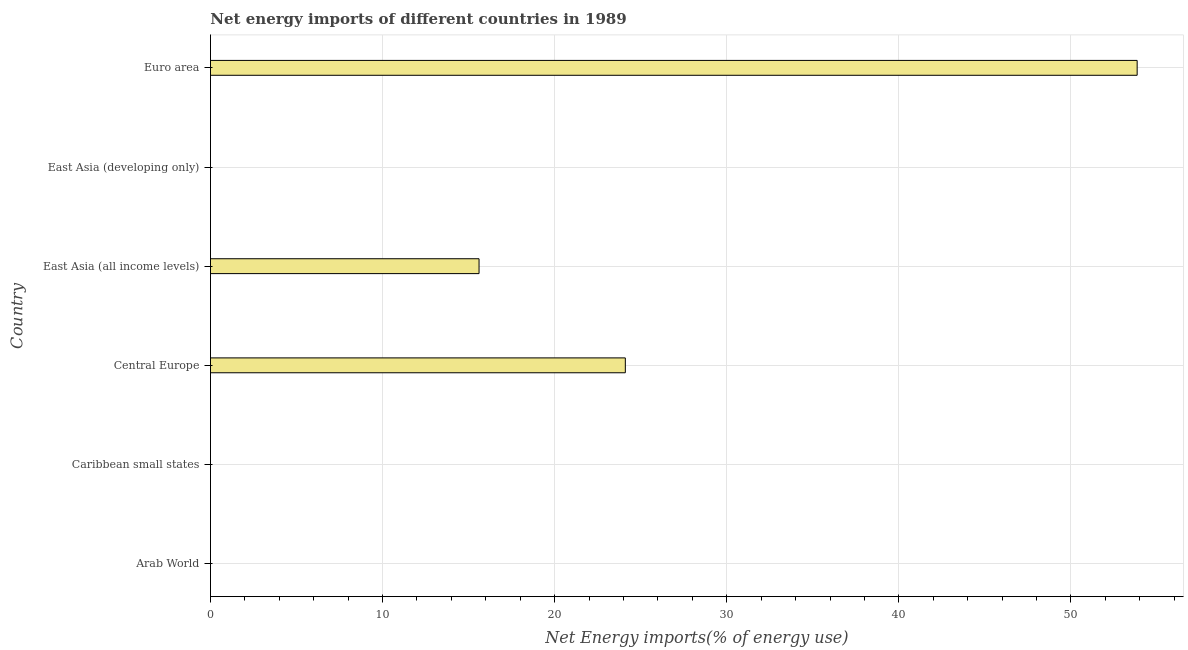Does the graph contain any zero values?
Ensure brevity in your answer.  Yes. What is the title of the graph?
Offer a terse response. Net energy imports of different countries in 1989. What is the label or title of the X-axis?
Your response must be concise. Net Energy imports(% of energy use). What is the label or title of the Y-axis?
Make the answer very short. Country. What is the energy imports in Caribbean small states?
Keep it short and to the point. 0. Across all countries, what is the maximum energy imports?
Keep it short and to the point. 53.85. Across all countries, what is the minimum energy imports?
Give a very brief answer. 0. In which country was the energy imports maximum?
Your response must be concise. Euro area. What is the sum of the energy imports?
Offer a very short reply. 93.56. What is the average energy imports per country?
Your answer should be compact. 15.59. What is the median energy imports?
Your response must be concise. 7.8. In how many countries, is the energy imports greater than 24 %?
Keep it short and to the point. 2. What is the ratio of the energy imports in East Asia (all income levels) to that in Euro area?
Your answer should be compact. 0.29. What is the difference between the highest and the second highest energy imports?
Make the answer very short. 29.74. Is the sum of the energy imports in East Asia (all income levels) and Euro area greater than the maximum energy imports across all countries?
Keep it short and to the point. Yes. What is the difference between the highest and the lowest energy imports?
Your answer should be compact. 53.85. In how many countries, is the energy imports greater than the average energy imports taken over all countries?
Your response must be concise. 3. How many bars are there?
Your response must be concise. 3. How many countries are there in the graph?
Offer a very short reply. 6. What is the difference between two consecutive major ticks on the X-axis?
Your response must be concise. 10. What is the Net Energy imports(% of energy use) in Caribbean small states?
Provide a short and direct response. 0. What is the Net Energy imports(% of energy use) in Central Europe?
Ensure brevity in your answer.  24.11. What is the Net Energy imports(% of energy use) of East Asia (all income levels)?
Give a very brief answer. 15.61. What is the Net Energy imports(% of energy use) of East Asia (developing only)?
Your response must be concise. 0. What is the Net Energy imports(% of energy use) of Euro area?
Offer a terse response. 53.85. What is the difference between the Net Energy imports(% of energy use) in Central Europe and East Asia (all income levels)?
Give a very brief answer. 8.5. What is the difference between the Net Energy imports(% of energy use) in Central Europe and Euro area?
Your answer should be very brief. -29.74. What is the difference between the Net Energy imports(% of energy use) in East Asia (all income levels) and Euro area?
Offer a very short reply. -38.24. What is the ratio of the Net Energy imports(% of energy use) in Central Europe to that in East Asia (all income levels)?
Your answer should be very brief. 1.54. What is the ratio of the Net Energy imports(% of energy use) in Central Europe to that in Euro area?
Give a very brief answer. 0.45. What is the ratio of the Net Energy imports(% of energy use) in East Asia (all income levels) to that in Euro area?
Provide a short and direct response. 0.29. 